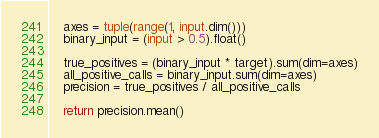Convert code to text. <code><loc_0><loc_0><loc_500><loc_500><_Python_>    axes = tuple(range(1, input.dim()))
    binary_input = (input > 0.5).float()

    true_positives = (binary_input * target).sum(dim=axes)
    all_positive_calls = binary_input.sum(dim=axes)
    precision = true_positives / all_positive_calls

    return precision.mean()
</code> 